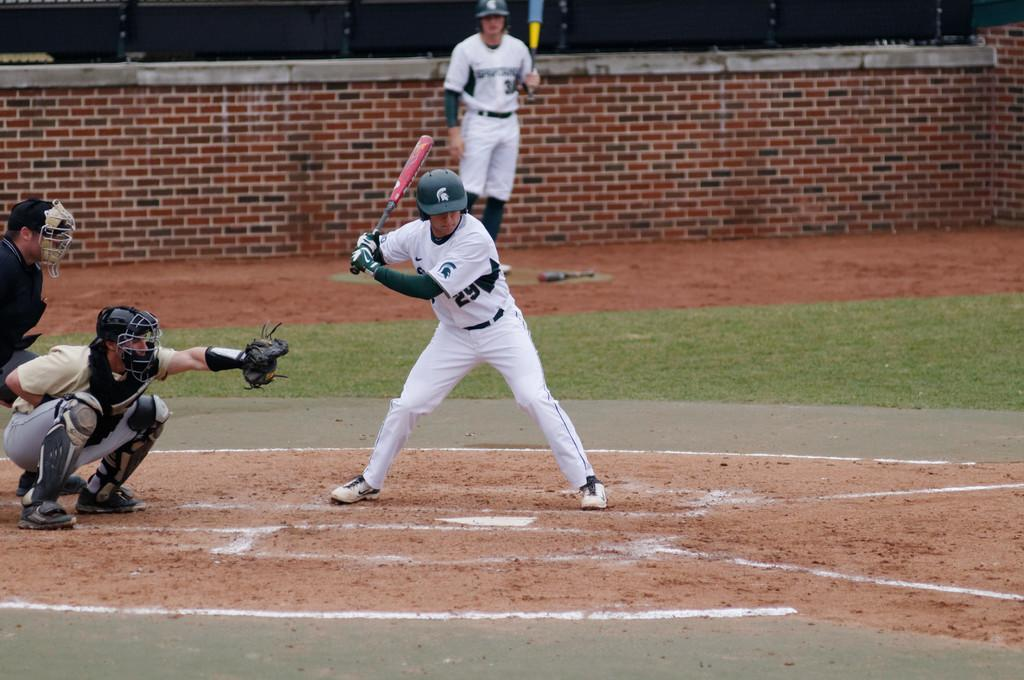What sport are the people playing in the image? The people are playing baseball in the image. What equipment are the players using? Two of the people are holding bats. What type of surface is visible in the image? There is grass visible in the image. What structure can be seen in the background? There is a wall in the image. Who is wearing a crown while playing baseball in the image? There is no one wearing a crown in the image; it is not mentioned in the provided facts. 